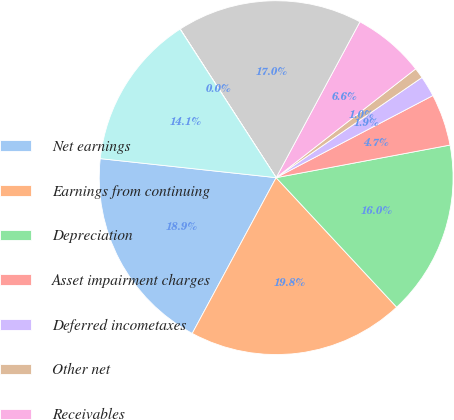Convert chart to OTSL. <chart><loc_0><loc_0><loc_500><loc_500><pie_chart><fcel>Net earnings<fcel>Earnings from continuing<fcel>Depreciation<fcel>Asset impairment charges<fcel>Deferred incometaxes<fcel>Other net<fcel>Receivables<fcel>Merchandise inventories<fcel>Other assets<fcel>Accounts payable<nl><fcel>18.85%<fcel>19.79%<fcel>16.02%<fcel>4.73%<fcel>1.9%<fcel>0.96%<fcel>6.61%<fcel>16.97%<fcel>0.02%<fcel>14.14%<nl></chart> 